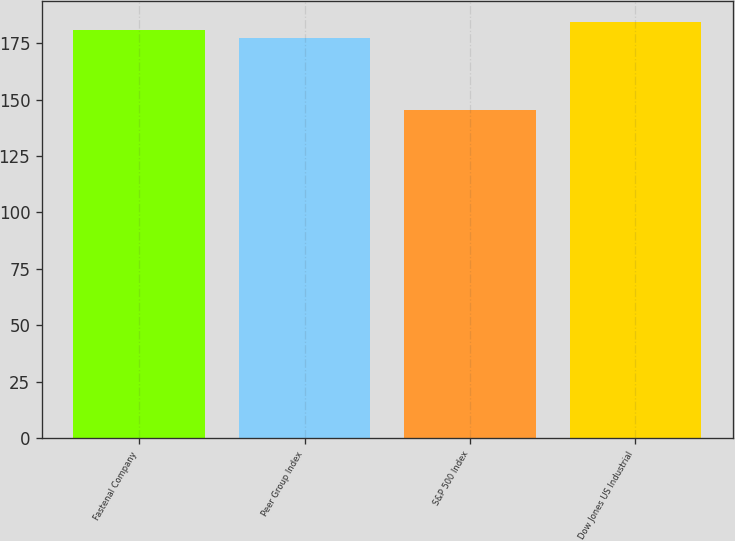Convert chart to OTSL. <chart><loc_0><loc_0><loc_500><loc_500><bar_chart><fcel>Fastenal Company<fcel>Peer Group Index<fcel>S&P 500 Index<fcel>Dow Jones US Industrial<nl><fcel>180.69<fcel>177.17<fcel>145.51<fcel>184.21<nl></chart> 